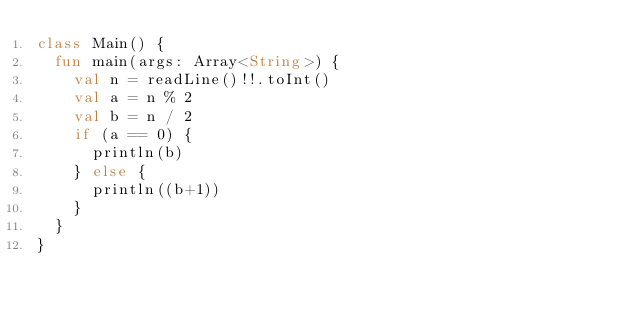Convert code to text. <code><loc_0><loc_0><loc_500><loc_500><_Kotlin_>class Main() {
  fun main(args: Array<String>) {
    val n = readLine()!!.toInt()
    val a = n % 2
    val b = n / 2
    if (a == 0) {
      println(b)
    } else {
      println((b+1))
    }
  }
}
    </code> 